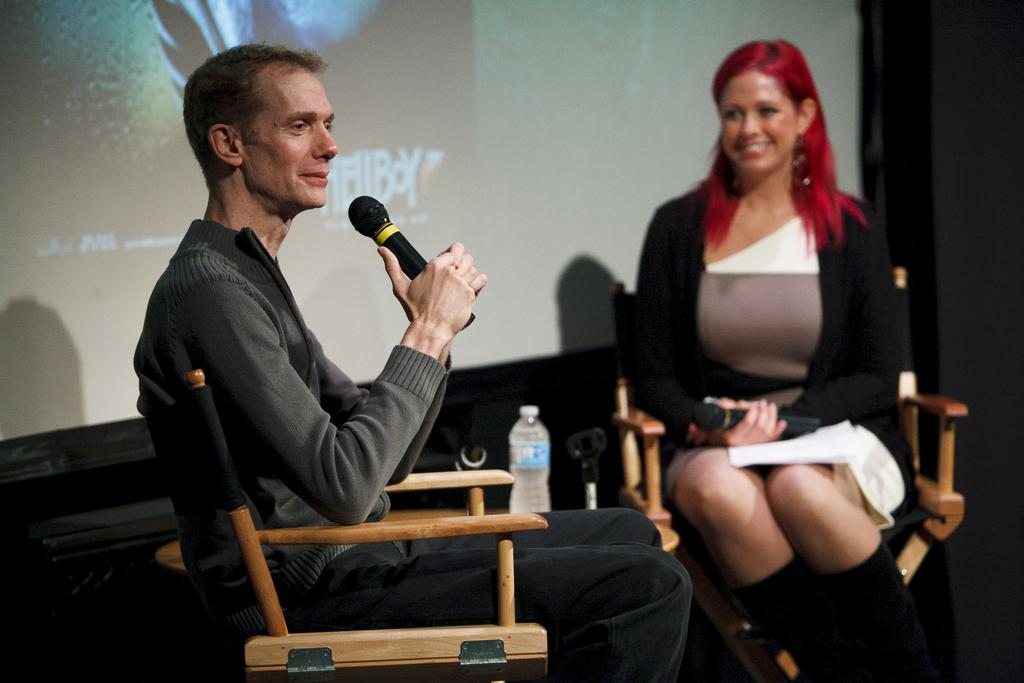What is the man in the image doing? The man is sitting and talking on a mic. Who else is in the image? There is a woman in the image. What is the woman doing? The woman is sitting and looking at the man. Where are the man and woman located in the image? Both the man and woman are on a stage. What type of transport is the beggar using in the image? There is no beggar present in the image, and therefore no transport can be observed. 